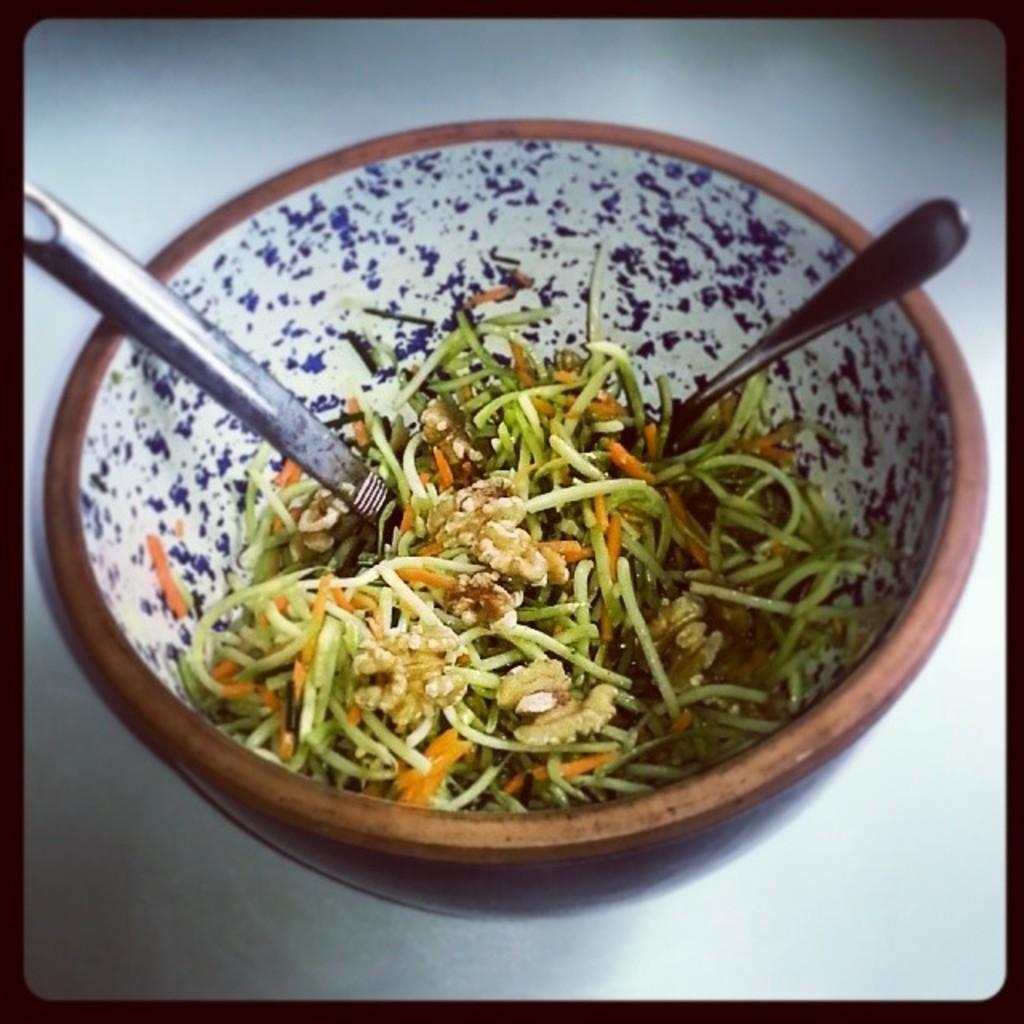What type of food can be seen in the image? There is food in the image, but the specific type is not mentioned. How is the food presented in the image? The food is in a bowl. What utensils are visible in the image? There are spoons in the image. How many brothers are depicted working on the plough in the image? There are no brothers or plough present in the image. 